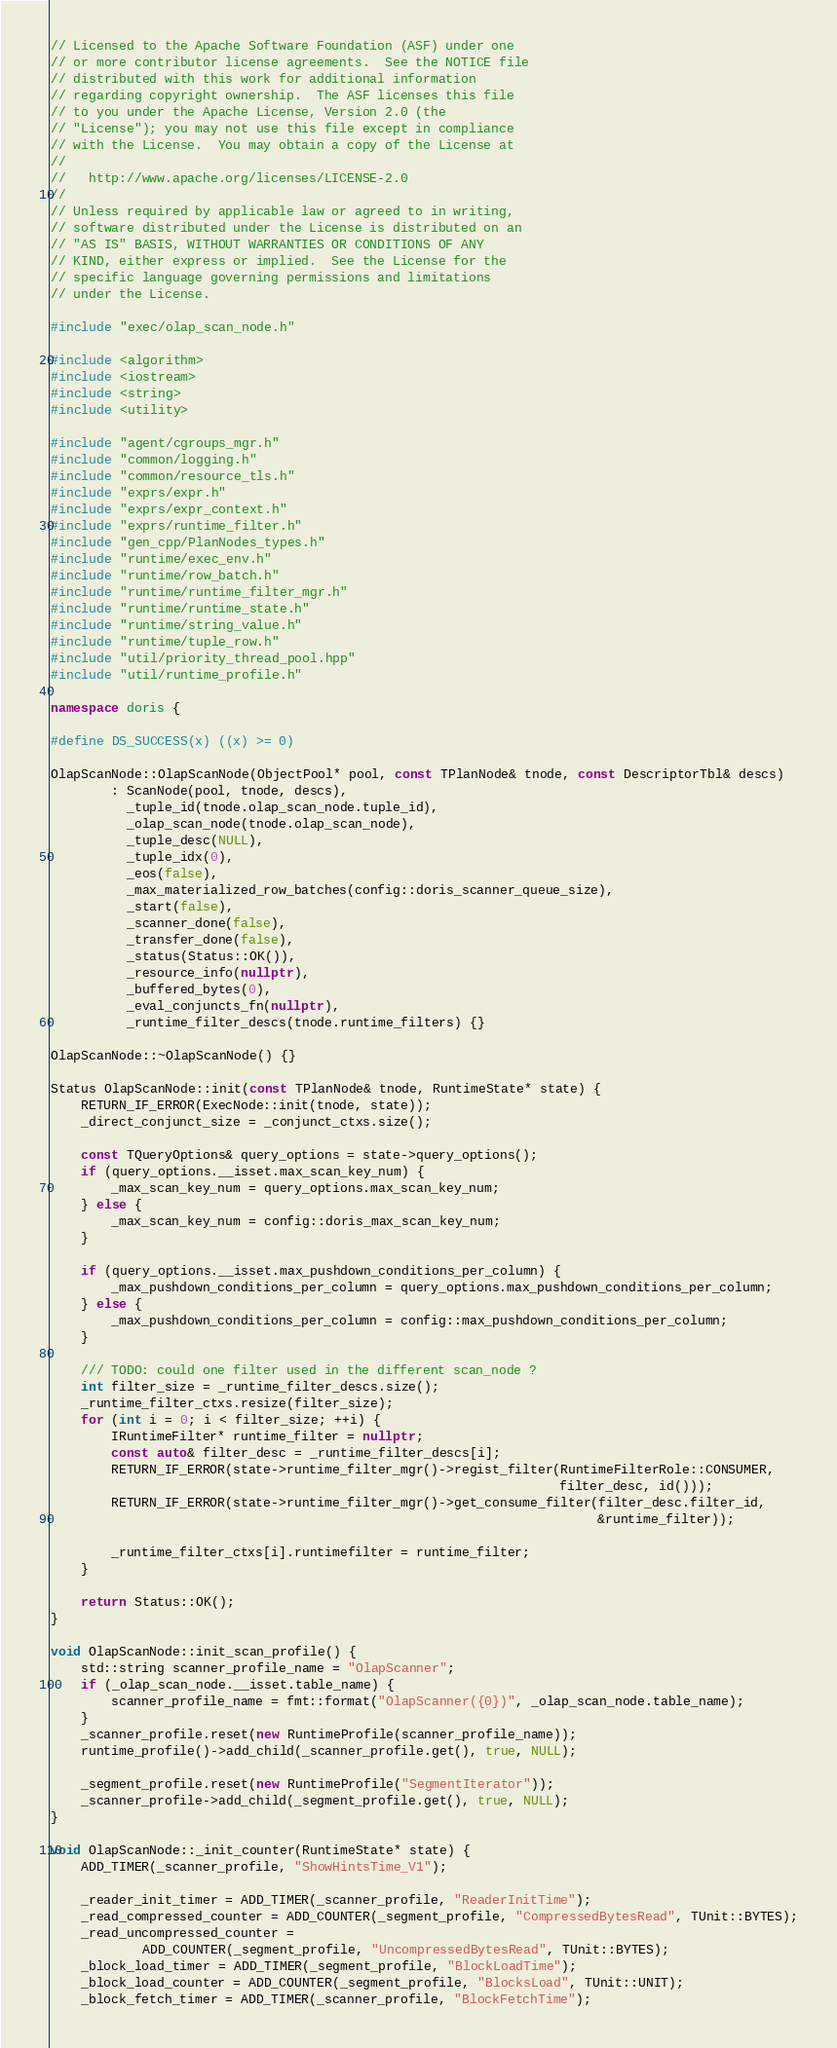<code> <loc_0><loc_0><loc_500><loc_500><_C++_>// Licensed to the Apache Software Foundation (ASF) under one
// or more contributor license agreements.  See the NOTICE file
// distributed with this work for additional information
// regarding copyright ownership.  The ASF licenses this file
// to you under the Apache License, Version 2.0 (the
// "License"); you may not use this file except in compliance
// with the License.  You may obtain a copy of the License at
//
//   http://www.apache.org/licenses/LICENSE-2.0
//
// Unless required by applicable law or agreed to in writing,
// software distributed under the License is distributed on an
// "AS IS" BASIS, WITHOUT WARRANTIES OR CONDITIONS OF ANY
// KIND, either express or implied.  See the License for the
// specific language governing permissions and limitations
// under the License.

#include "exec/olap_scan_node.h"

#include <algorithm>
#include <iostream>
#include <string>
#include <utility>

#include "agent/cgroups_mgr.h"
#include "common/logging.h"
#include "common/resource_tls.h"
#include "exprs/expr.h"
#include "exprs/expr_context.h"
#include "exprs/runtime_filter.h"
#include "gen_cpp/PlanNodes_types.h"
#include "runtime/exec_env.h"
#include "runtime/row_batch.h"
#include "runtime/runtime_filter_mgr.h"
#include "runtime/runtime_state.h"
#include "runtime/string_value.h"
#include "runtime/tuple_row.h"
#include "util/priority_thread_pool.hpp"
#include "util/runtime_profile.h"

namespace doris {

#define DS_SUCCESS(x) ((x) >= 0)

OlapScanNode::OlapScanNode(ObjectPool* pool, const TPlanNode& tnode, const DescriptorTbl& descs)
        : ScanNode(pool, tnode, descs),
          _tuple_id(tnode.olap_scan_node.tuple_id),
          _olap_scan_node(tnode.olap_scan_node),
          _tuple_desc(NULL),
          _tuple_idx(0),
          _eos(false),
          _max_materialized_row_batches(config::doris_scanner_queue_size),
          _start(false),
          _scanner_done(false),
          _transfer_done(false),
          _status(Status::OK()),
          _resource_info(nullptr),
          _buffered_bytes(0),
          _eval_conjuncts_fn(nullptr),
          _runtime_filter_descs(tnode.runtime_filters) {}

OlapScanNode::~OlapScanNode() {}

Status OlapScanNode::init(const TPlanNode& tnode, RuntimeState* state) {
    RETURN_IF_ERROR(ExecNode::init(tnode, state));
    _direct_conjunct_size = _conjunct_ctxs.size();

    const TQueryOptions& query_options = state->query_options();
    if (query_options.__isset.max_scan_key_num) {
        _max_scan_key_num = query_options.max_scan_key_num;
    } else {
        _max_scan_key_num = config::doris_max_scan_key_num;
    }

    if (query_options.__isset.max_pushdown_conditions_per_column) {
        _max_pushdown_conditions_per_column = query_options.max_pushdown_conditions_per_column;
    } else {
        _max_pushdown_conditions_per_column = config::max_pushdown_conditions_per_column;
    }

    /// TODO: could one filter used in the different scan_node ?
    int filter_size = _runtime_filter_descs.size();
    _runtime_filter_ctxs.resize(filter_size);
    for (int i = 0; i < filter_size; ++i) {
        IRuntimeFilter* runtime_filter = nullptr;
        const auto& filter_desc = _runtime_filter_descs[i];
        RETURN_IF_ERROR(state->runtime_filter_mgr()->regist_filter(RuntimeFilterRole::CONSUMER,
                                                                   filter_desc, id()));
        RETURN_IF_ERROR(state->runtime_filter_mgr()->get_consume_filter(filter_desc.filter_id,
                                                                        &runtime_filter));

        _runtime_filter_ctxs[i].runtimefilter = runtime_filter;
    }

    return Status::OK();
}

void OlapScanNode::init_scan_profile() {
    std::string scanner_profile_name = "OlapScanner";
    if (_olap_scan_node.__isset.table_name) {
        scanner_profile_name = fmt::format("OlapScanner({0})", _olap_scan_node.table_name);
    }
    _scanner_profile.reset(new RuntimeProfile(scanner_profile_name));
    runtime_profile()->add_child(_scanner_profile.get(), true, NULL);

    _segment_profile.reset(new RuntimeProfile("SegmentIterator"));
    _scanner_profile->add_child(_segment_profile.get(), true, NULL);
}

void OlapScanNode::_init_counter(RuntimeState* state) {
    ADD_TIMER(_scanner_profile, "ShowHintsTime_V1");

    _reader_init_timer = ADD_TIMER(_scanner_profile, "ReaderInitTime");
    _read_compressed_counter = ADD_COUNTER(_segment_profile, "CompressedBytesRead", TUnit::BYTES);
    _read_uncompressed_counter =
            ADD_COUNTER(_segment_profile, "UncompressedBytesRead", TUnit::BYTES);
    _block_load_timer = ADD_TIMER(_segment_profile, "BlockLoadTime");
    _block_load_counter = ADD_COUNTER(_segment_profile, "BlocksLoad", TUnit::UNIT);
    _block_fetch_timer = ADD_TIMER(_scanner_profile, "BlockFetchTime");</code> 